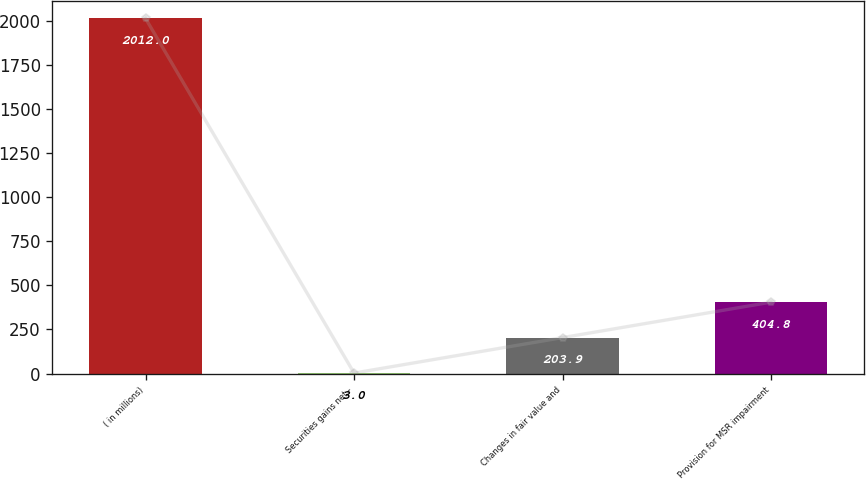Convert chart. <chart><loc_0><loc_0><loc_500><loc_500><bar_chart><fcel>( in millions)<fcel>Securities gains net -<fcel>Changes in fair value and<fcel>Provision for MSR impairment<nl><fcel>2012<fcel>3<fcel>203.9<fcel>404.8<nl></chart> 